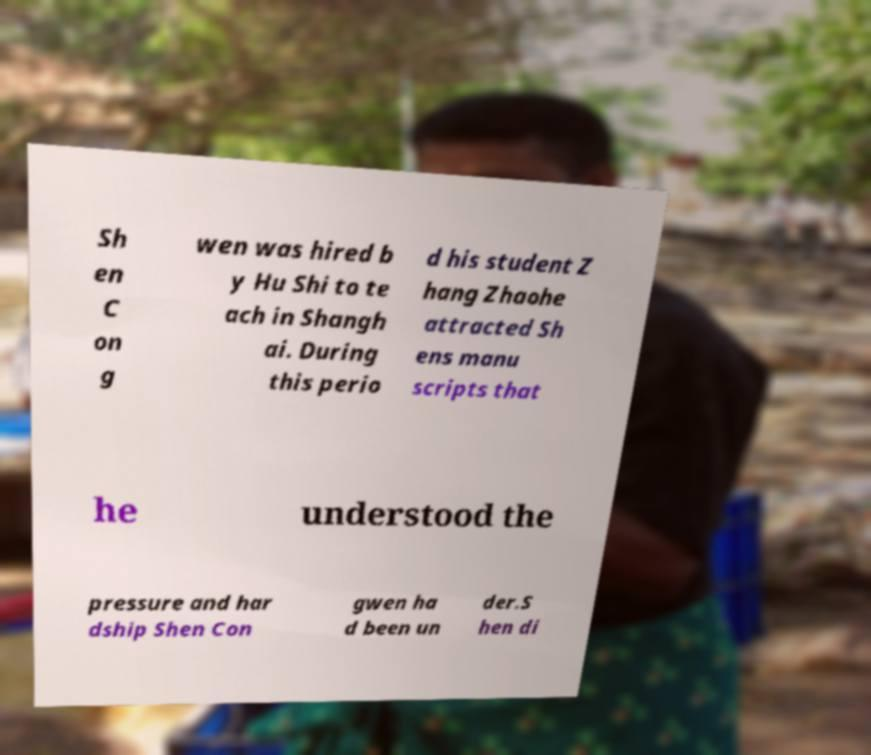I need the written content from this picture converted into text. Can you do that? Sh en C on g wen was hired b y Hu Shi to te ach in Shangh ai. During this perio d his student Z hang Zhaohe attracted Sh ens manu scripts that he understood the pressure and har dship Shen Con gwen ha d been un der.S hen di 